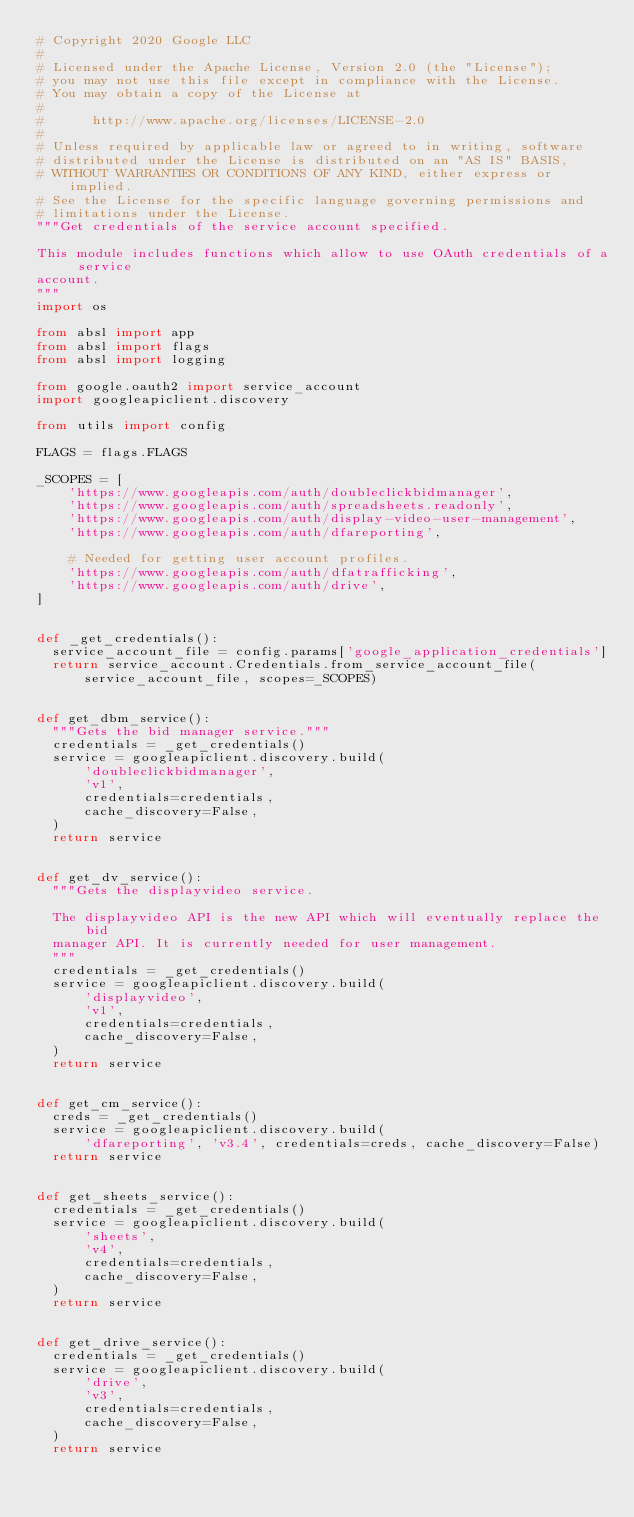Convert code to text. <code><loc_0><loc_0><loc_500><loc_500><_Python_># Copyright 2020 Google LLC
#
# Licensed under the Apache License, Version 2.0 (the "License");
# you may not use this file except in compliance with the License.
# You may obtain a copy of the License at
#
#      http://www.apache.org/licenses/LICENSE-2.0
#
# Unless required by applicable law or agreed to in writing, software
# distributed under the License is distributed on an "AS IS" BASIS,
# WITHOUT WARRANTIES OR CONDITIONS OF ANY KIND, either express or implied.
# See the License for the specific language governing permissions and
# limitations under the License.
"""Get credentials of the service account specified.

This module includes functions which allow to use OAuth credentials of a service
account.
"""
import os

from absl import app
from absl import flags
from absl import logging

from google.oauth2 import service_account
import googleapiclient.discovery

from utils import config

FLAGS = flags.FLAGS

_SCOPES = [
    'https://www.googleapis.com/auth/doubleclickbidmanager',
    'https://www.googleapis.com/auth/spreadsheets.readonly',
    'https://www.googleapis.com/auth/display-video-user-management',
    'https://www.googleapis.com/auth/dfareporting',

    # Needed for getting user account profiles.
    'https://www.googleapis.com/auth/dfatrafficking',
    'https://www.googleapis.com/auth/drive',
]


def _get_credentials():
  service_account_file = config.params['google_application_credentials']
  return service_account.Credentials.from_service_account_file(
      service_account_file, scopes=_SCOPES)


def get_dbm_service():
  """Gets the bid manager service."""
  credentials = _get_credentials()
  service = googleapiclient.discovery.build(
      'doubleclickbidmanager',
      'v1',
      credentials=credentials,
      cache_discovery=False,
  )
  return service


def get_dv_service():
  """Gets the displayvideo service.

  The displayvideo API is the new API which will eventually replace the bid
  manager API. It is currently needed for user management.
  """
  credentials = _get_credentials()
  service = googleapiclient.discovery.build(
      'displayvideo',
      'v1',
      credentials=credentials,
      cache_discovery=False,
  )
  return service


def get_cm_service():
  creds = _get_credentials()
  service = googleapiclient.discovery.build(
      'dfareporting', 'v3.4', credentials=creds, cache_discovery=False)
  return service


def get_sheets_service():
  credentials = _get_credentials()
  service = googleapiclient.discovery.build(
      'sheets',
      'v4',
      credentials=credentials,
      cache_discovery=False,
  )
  return service


def get_drive_service():
  credentials = _get_credentials()
  service = googleapiclient.discovery.build(
      'drive',
      'v3',
      credentials=credentials,
      cache_discovery=False,
  )
  return service
</code> 